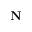Convert formula to latex. <formula><loc_0><loc_0><loc_500><loc_500>N</formula> 